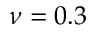<formula> <loc_0><loc_0><loc_500><loc_500>\nu = 0 . 3</formula> 